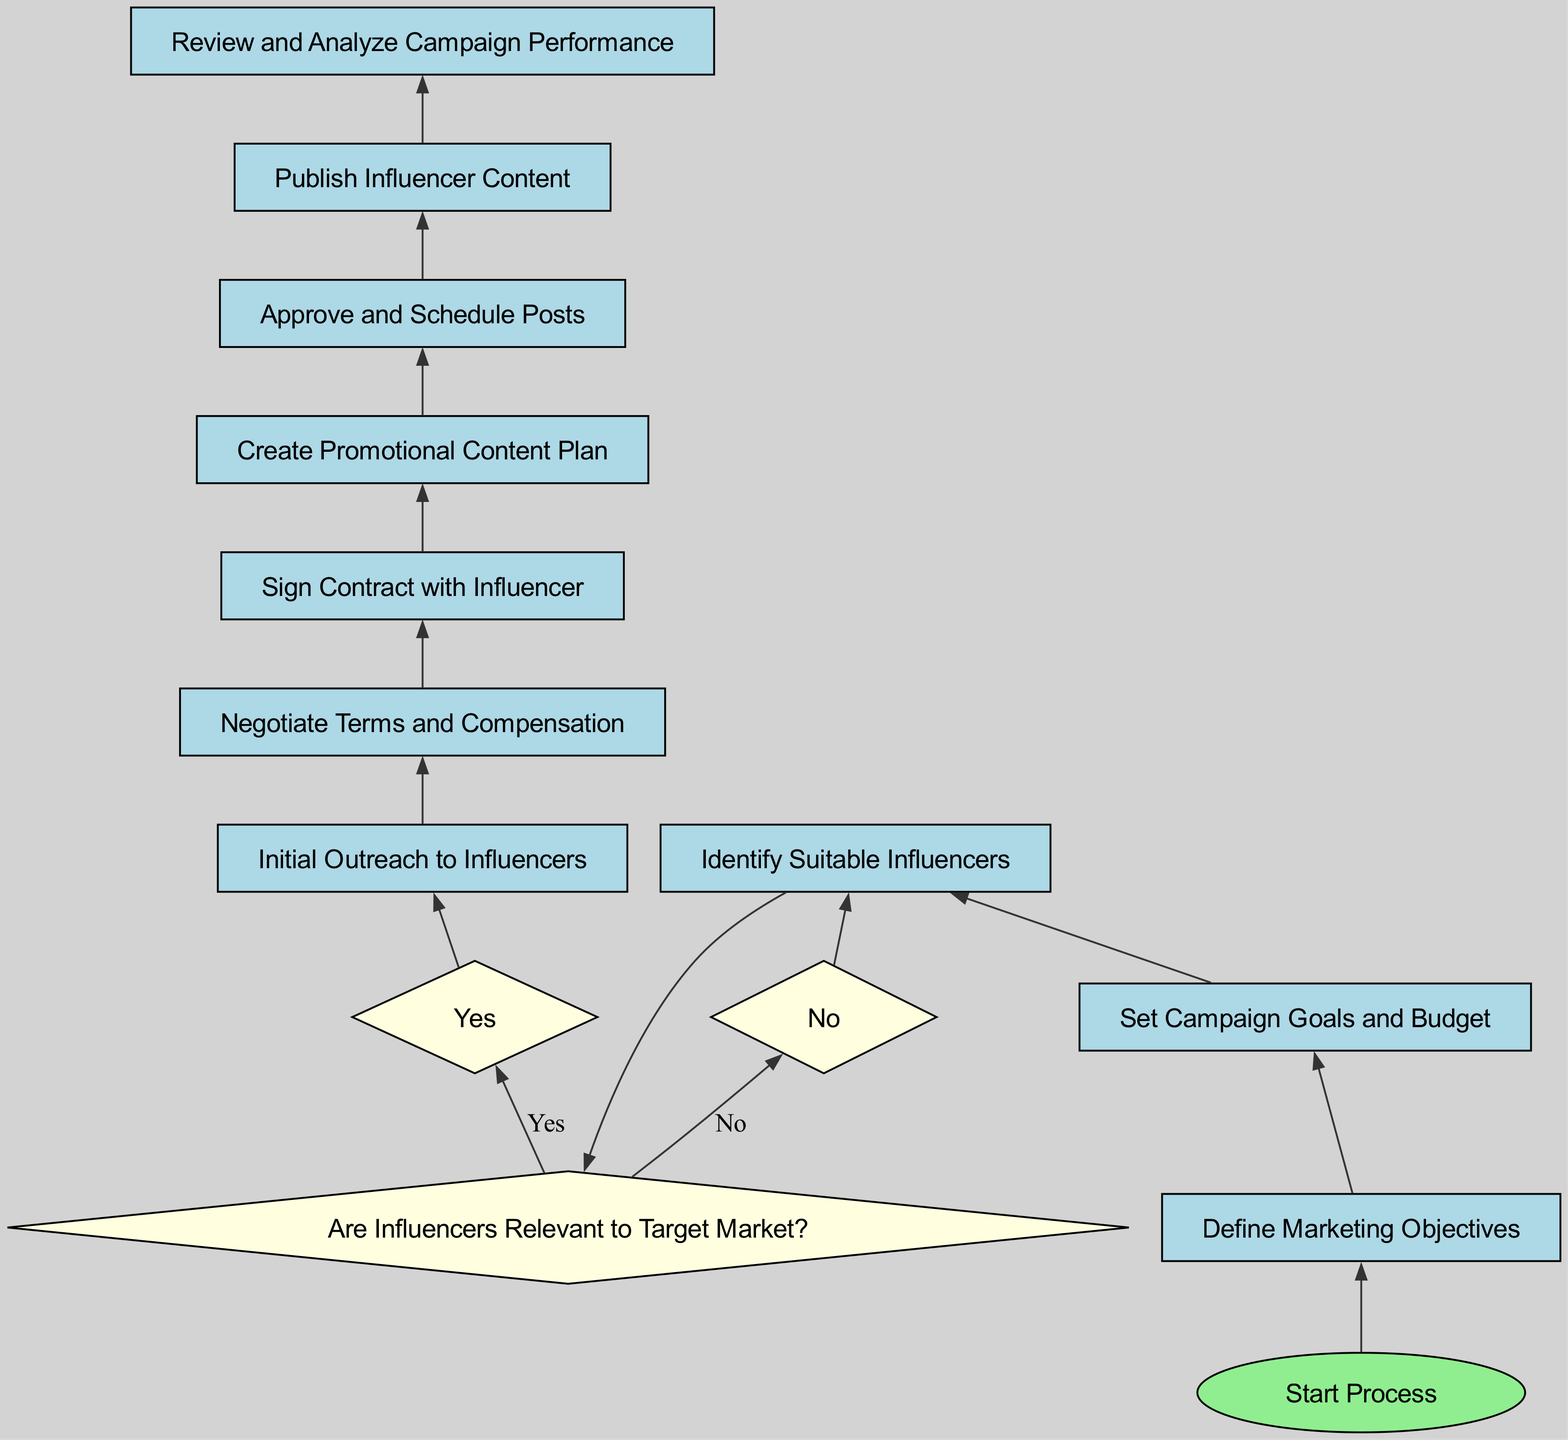What is the first step in the process? The diagram indicates that the flow starts with the "Start Process" node, which is represented as the first step leading to other processes in the chart.
Answer: Start Process How many decision points are in the diagram? By analyzing the elements in the diagram, we see that there are three decision points: "Are Influencers Relevant to Target Market?" and two "Yes" and "No" outcomes.
Answer: Two What process follows after "Sign Contract with Influencer"? According to the flow of the diagram, after "Sign Contract with Influencer", the next process in the sequence is "Create Promotional Content Plan".
Answer: Create Promotional Content Plan What happens if influencers are not relevant to the target market? The diagram shows that if influencers are determined to be not relevant, the process loops back to "Identify Suitable Influencers", indicating the need to reconsider and find appropriate influencers.
Answer: Identify Suitable Influencers What is the last process in the diagram? Reviewing the flow of the diagram, the final process before the output is "Review and Analyze Campaign Performance", which signifies the completion of the influencer collaboration process.
Answer: Review and Analyze Campaign Performance In which step do you negotiate terms and compensation? The diagram illustrates that the "Negotiate Terms and Compensation" step follows the "Initial Outreach to Influencers" process, emphasizing its position in the sequence of collaboration steps.
Answer: Negotiate Terms and Compensation Which node directly leads to "Publish Influencer Content"? Examining the flow, the step that directly leads into "Publish Influencer Content" is "Approve and Schedule Posts", suggesting that approval is necessary before content publication.
Answer: Approve and Schedule Posts 